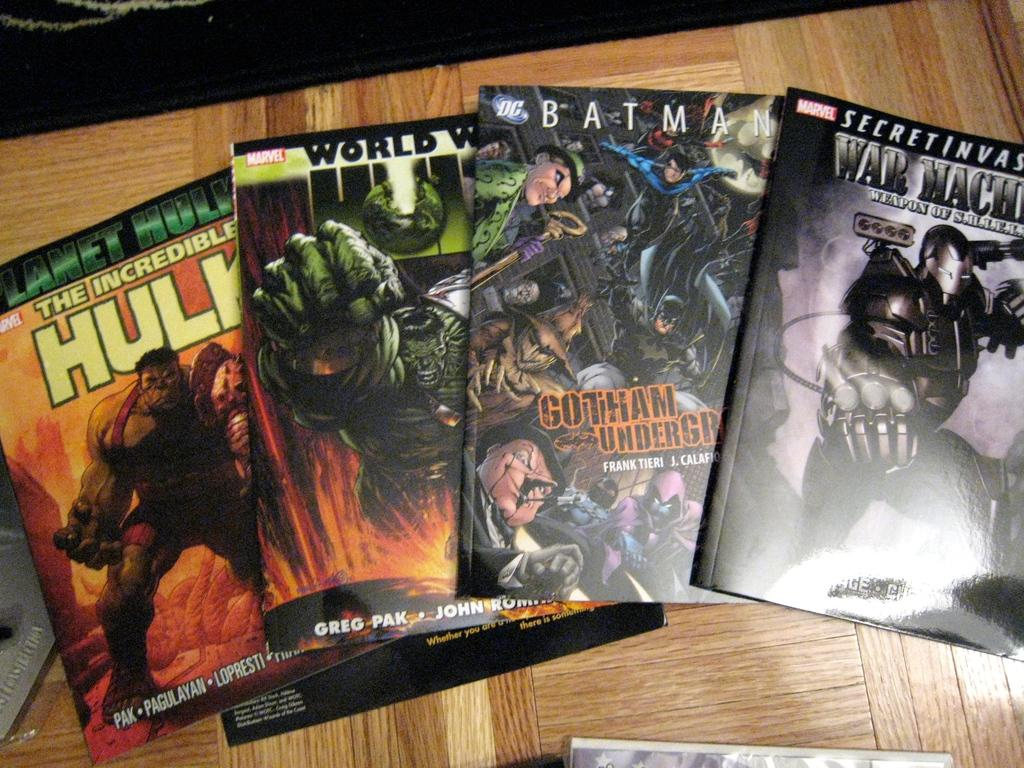<image>
Provide a brief description of the given image. Marvel and DC comics are spread out on a table. 